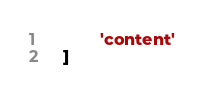<code> <loc_0><loc_0><loc_500><loc_500><_Python_>            'content'
    ]</code> 